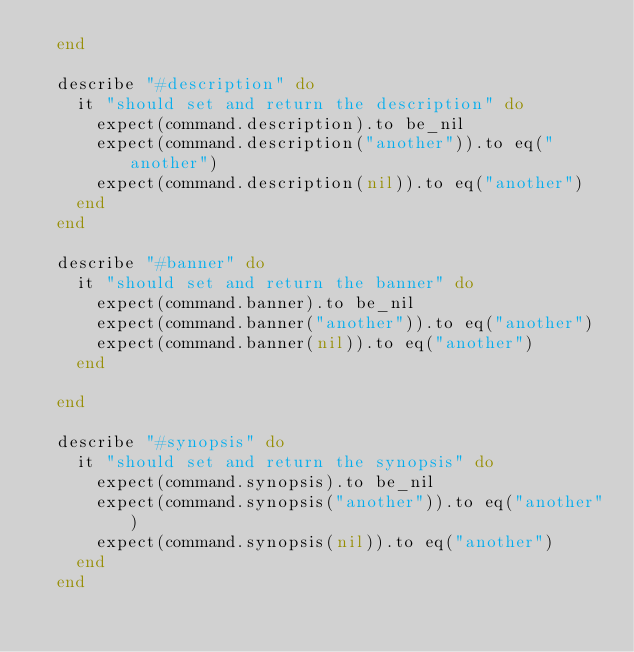<code> <loc_0><loc_0><loc_500><loc_500><_Ruby_>  end

  describe "#description" do
    it "should set and return the description" do
      expect(command.description).to be_nil
      expect(command.description("another")).to eq("another")
      expect(command.description(nil)).to eq("another")
    end
  end

  describe "#banner" do
    it "should set and return the banner" do
      expect(command.banner).to be_nil
      expect(command.banner("another")).to eq("another")
      expect(command.banner(nil)).to eq("another")
    end

  end

  describe "#synopsis" do
    it "should set and return the synopsis" do
      expect(command.synopsis).to be_nil
      expect(command.synopsis("another")).to eq("another")
      expect(command.synopsis(nil)).to eq("another")
    end
  end
</code> 